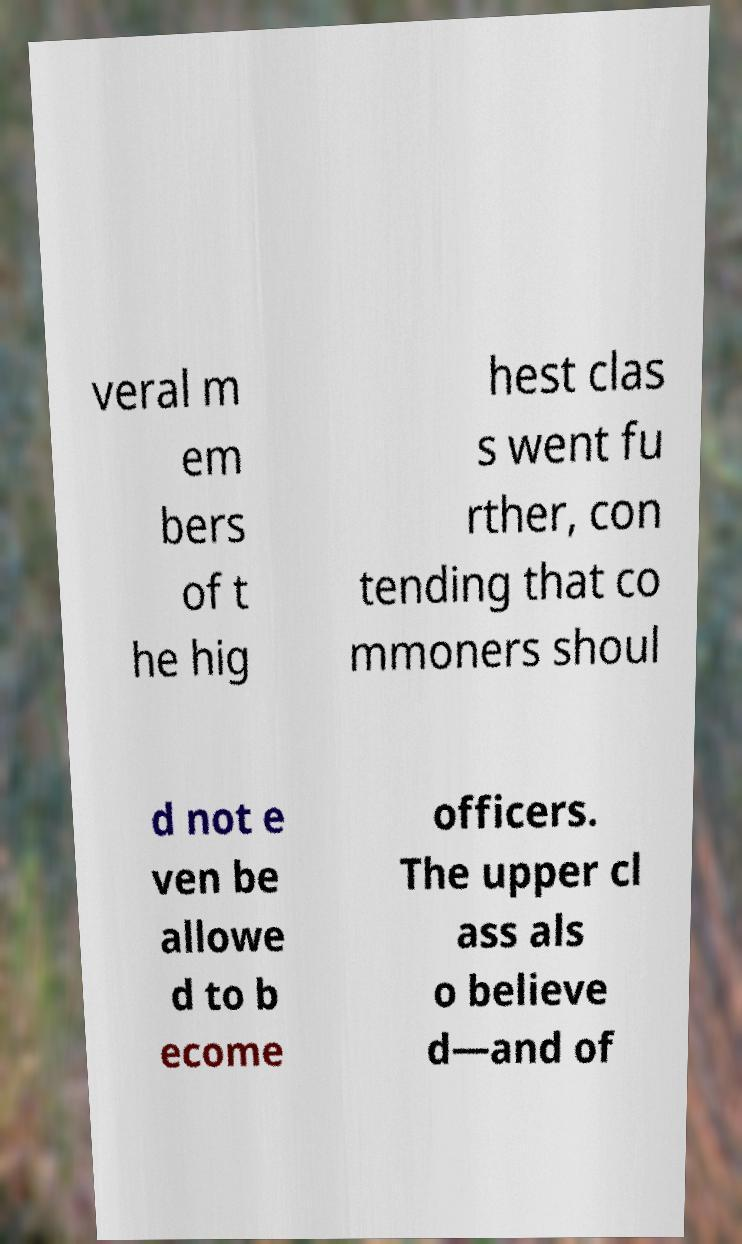Could you assist in decoding the text presented in this image and type it out clearly? veral m em bers of t he hig hest clas s went fu rther, con tending that co mmoners shoul d not e ven be allowe d to b ecome officers. The upper cl ass als o believe d—and of 